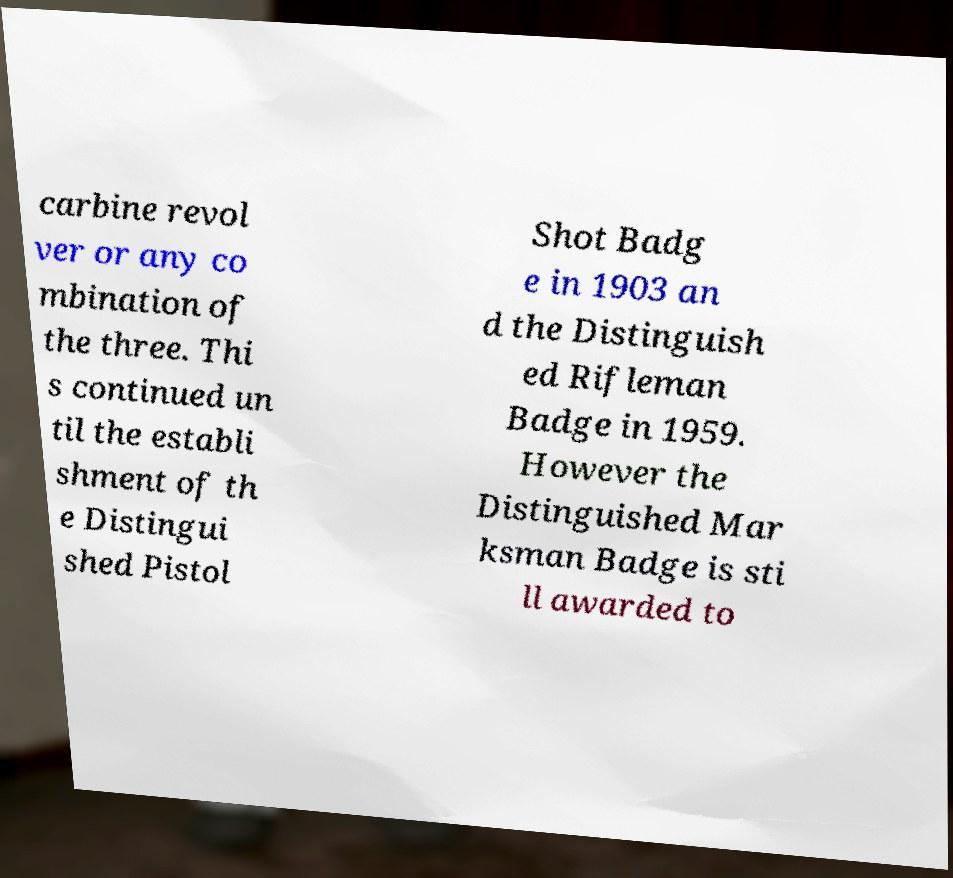I need the written content from this picture converted into text. Can you do that? carbine revol ver or any co mbination of the three. Thi s continued un til the establi shment of th e Distingui shed Pistol Shot Badg e in 1903 an d the Distinguish ed Rifleman Badge in 1959. However the Distinguished Mar ksman Badge is sti ll awarded to 